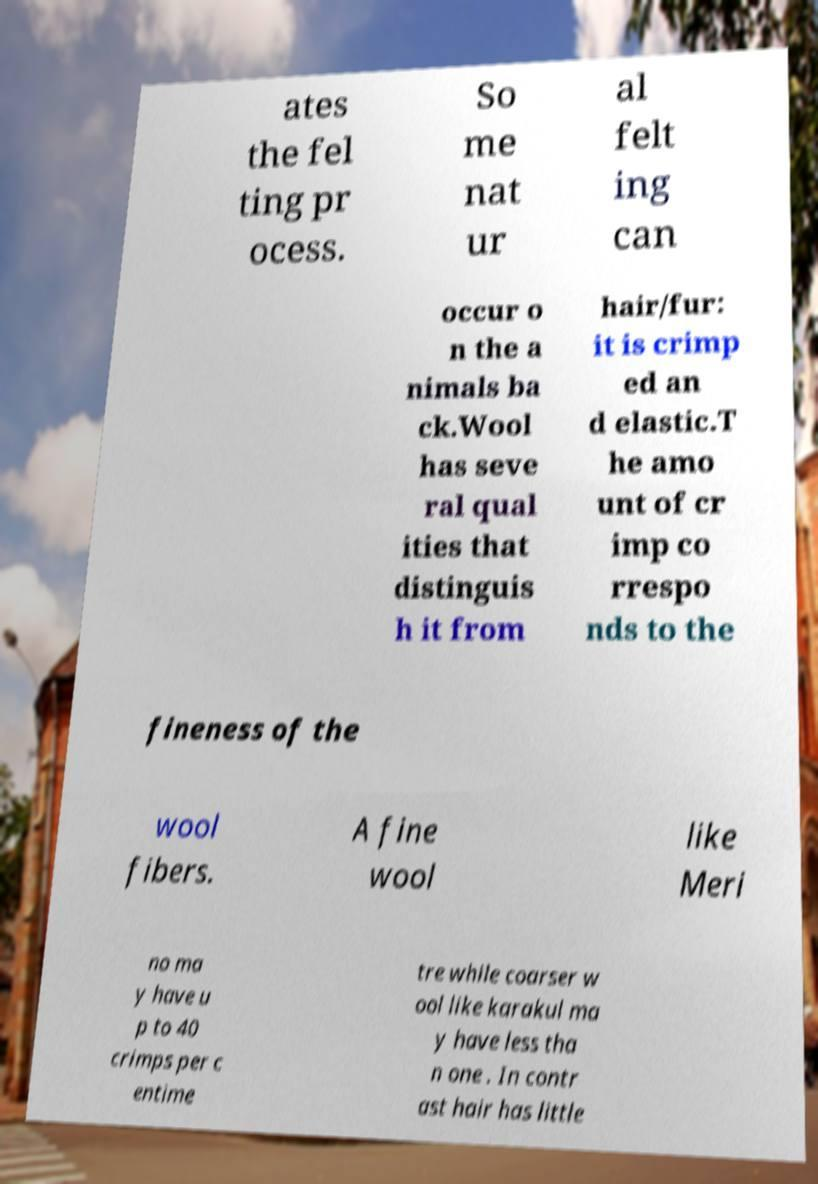There's text embedded in this image that I need extracted. Can you transcribe it verbatim? ates the fel ting pr ocess. So me nat ur al felt ing can occur o n the a nimals ba ck.Wool has seve ral qual ities that distinguis h it from hair/fur: it is crimp ed an d elastic.T he amo unt of cr imp co rrespo nds to the fineness of the wool fibers. A fine wool like Meri no ma y have u p to 40 crimps per c entime tre while coarser w ool like karakul ma y have less tha n one . In contr ast hair has little 